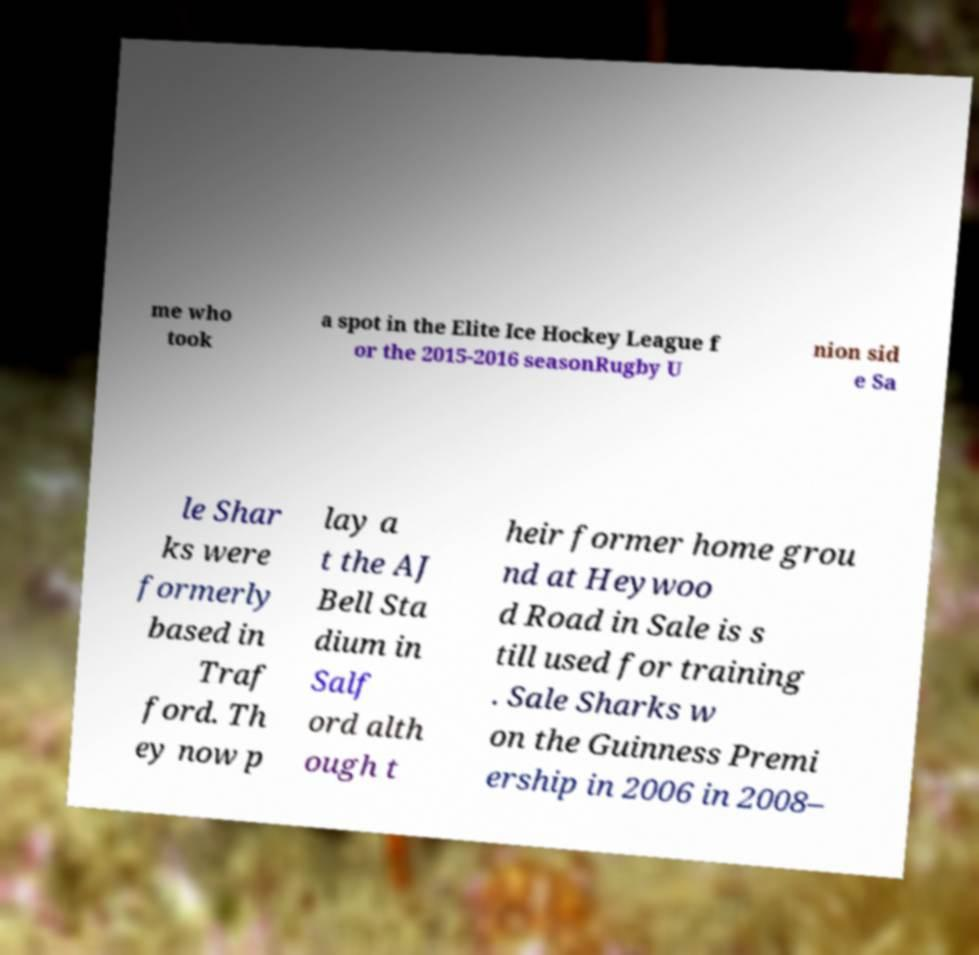Please read and relay the text visible in this image. What does it say? me who took a spot in the Elite Ice Hockey League f or the 2015-2016 seasonRugby U nion sid e Sa le Shar ks were formerly based in Traf ford. Th ey now p lay a t the AJ Bell Sta dium in Salf ord alth ough t heir former home grou nd at Heywoo d Road in Sale is s till used for training . Sale Sharks w on the Guinness Premi ership in 2006 in 2008– 